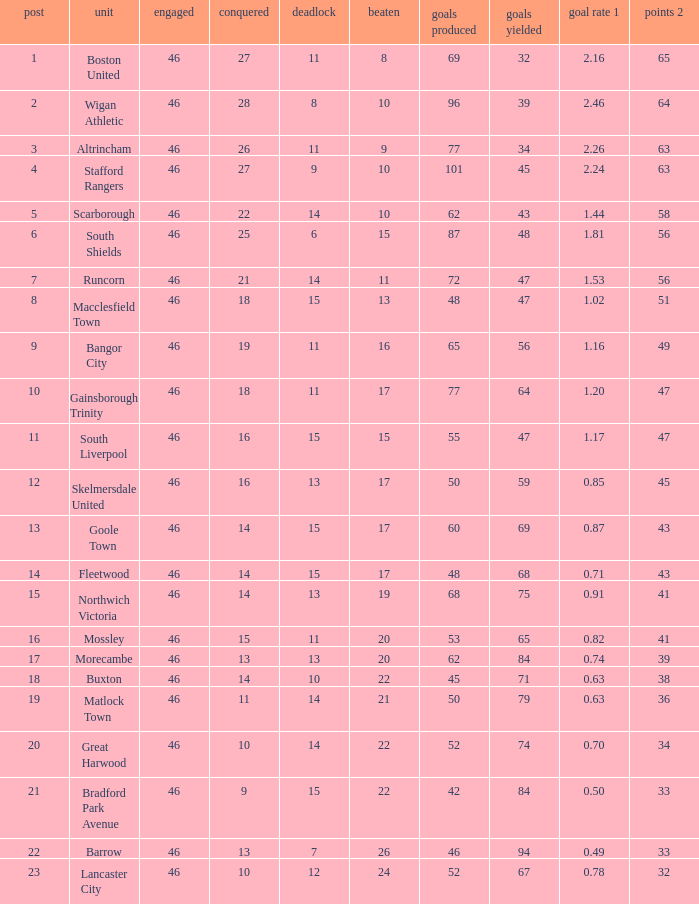How many games did the team who scored 60 goals win? 14.0. 